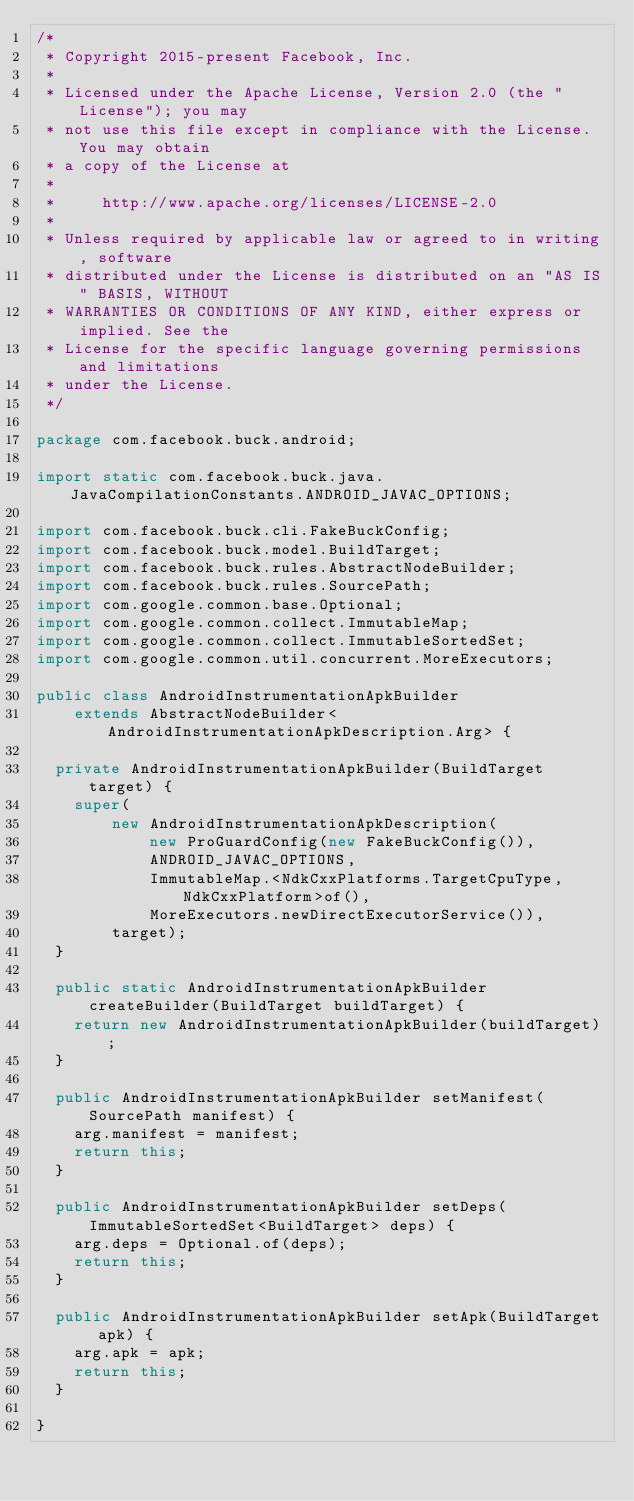Convert code to text. <code><loc_0><loc_0><loc_500><loc_500><_Java_>/*
 * Copyright 2015-present Facebook, Inc.
 *
 * Licensed under the Apache License, Version 2.0 (the "License"); you may
 * not use this file except in compliance with the License. You may obtain
 * a copy of the License at
 *
 *     http://www.apache.org/licenses/LICENSE-2.0
 *
 * Unless required by applicable law or agreed to in writing, software
 * distributed under the License is distributed on an "AS IS" BASIS, WITHOUT
 * WARRANTIES OR CONDITIONS OF ANY KIND, either express or implied. See the
 * License for the specific language governing permissions and limitations
 * under the License.
 */

package com.facebook.buck.android;

import static com.facebook.buck.java.JavaCompilationConstants.ANDROID_JAVAC_OPTIONS;

import com.facebook.buck.cli.FakeBuckConfig;
import com.facebook.buck.model.BuildTarget;
import com.facebook.buck.rules.AbstractNodeBuilder;
import com.facebook.buck.rules.SourcePath;
import com.google.common.base.Optional;
import com.google.common.collect.ImmutableMap;
import com.google.common.collect.ImmutableSortedSet;
import com.google.common.util.concurrent.MoreExecutors;

public class AndroidInstrumentationApkBuilder
    extends AbstractNodeBuilder<AndroidInstrumentationApkDescription.Arg> {

  private AndroidInstrumentationApkBuilder(BuildTarget target) {
    super(
        new AndroidInstrumentationApkDescription(
            new ProGuardConfig(new FakeBuckConfig()),
            ANDROID_JAVAC_OPTIONS,
            ImmutableMap.<NdkCxxPlatforms.TargetCpuType, NdkCxxPlatform>of(),
            MoreExecutors.newDirectExecutorService()),
        target);
  }

  public static AndroidInstrumentationApkBuilder createBuilder(BuildTarget buildTarget) {
    return new AndroidInstrumentationApkBuilder(buildTarget);
  }

  public AndroidInstrumentationApkBuilder setManifest(SourcePath manifest) {
    arg.manifest = manifest;
    return this;
  }

  public AndroidInstrumentationApkBuilder setDeps(ImmutableSortedSet<BuildTarget> deps) {
    arg.deps = Optional.of(deps);
    return this;
  }

  public AndroidInstrumentationApkBuilder setApk(BuildTarget apk) {
    arg.apk = apk;
    return this;
  }

}
</code> 